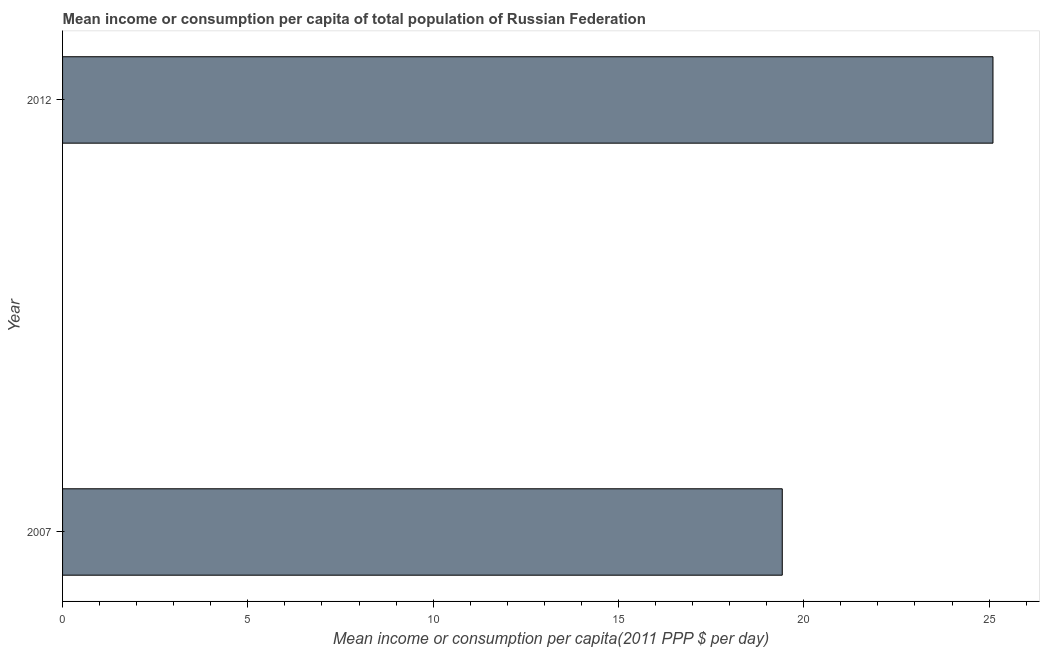Does the graph contain any zero values?
Ensure brevity in your answer.  No. What is the title of the graph?
Provide a short and direct response. Mean income or consumption per capita of total population of Russian Federation. What is the label or title of the X-axis?
Offer a very short reply. Mean income or consumption per capita(2011 PPP $ per day). What is the label or title of the Y-axis?
Offer a terse response. Year. What is the mean income or consumption in 2007?
Your response must be concise. 19.42. Across all years, what is the maximum mean income or consumption?
Make the answer very short. 25.11. Across all years, what is the minimum mean income or consumption?
Give a very brief answer. 19.42. What is the sum of the mean income or consumption?
Your answer should be compact. 44.53. What is the difference between the mean income or consumption in 2007 and 2012?
Provide a succinct answer. -5.69. What is the average mean income or consumption per year?
Give a very brief answer. 22.26. What is the median mean income or consumption?
Your response must be concise. 22.26. In how many years, is the mean income or consumption greater than 12 $?
Provide a succinct answer. 2. Do a majority of the years between 2007 and 2012 (inclusive) have mean income or consumption greater than 6 $?
Offer a terse response. Yes. What is the ratio of the mean income or consumption in 2007 to that in 2012?
Offer a very short reply. 0.77. How many bars are there?
Your answer should be very brief. 2. Are all the bars in the graph horizontal?
Offer a terse response. Yes. What is the difference between two consecutive major ticks on the X-axis?
Your answer should be very brief. 5. What is the Mean income or consumption per capita(2011 PPP $ per day) of 2007?
Offer a terse response. 19.42. What is the Mean income or consumption per capita(2011 PPP $ per day) in 2012?
Your answer should be compact. 25.11. What is the difference between the Mean income or consumption per capita(2011 PPP $ per day) in 2007 and 2012?
Your response must be concise. -5.69. What is the ratio of the Mean income or consumption per capita(2011 PPP $ per day) in 2007 to that in 2012?
Your response must be concise. 0.77. 